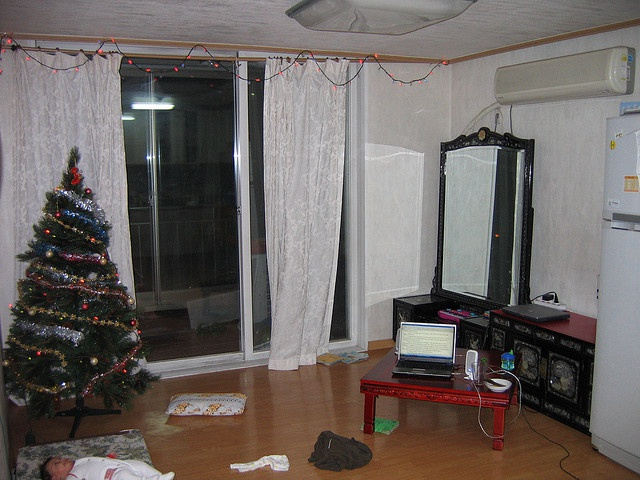Describe the objects in this image and their specific colors. I can see refrigerator in gray and darkgray tones, laptop in gray, black, darkgray, and beige tones, people in gray, darkgray, lightgray, and brown tones, laptop in gray and black tones, and bowl in gray, darkgray, black, and lightgray tones in this image. 